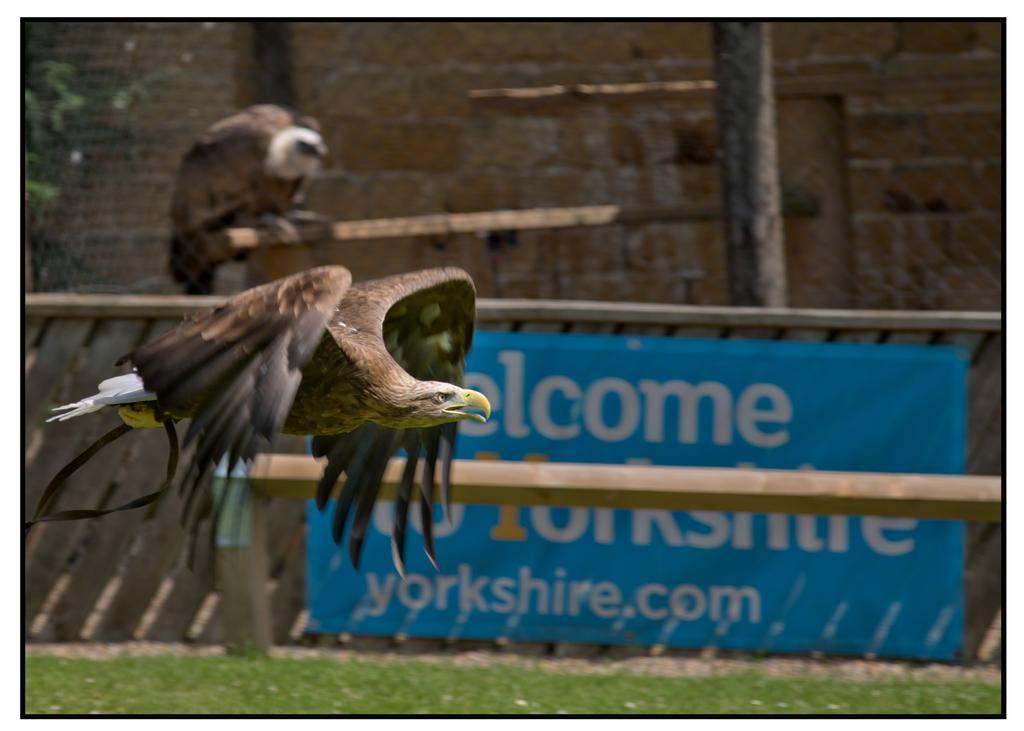Can you describe this image briefly? In this picture I can see a bird flying and I can see another bird on the stick in the back and I can see a tree and a board with some text and I can see a wall in the back and I can see grass on the ground. 